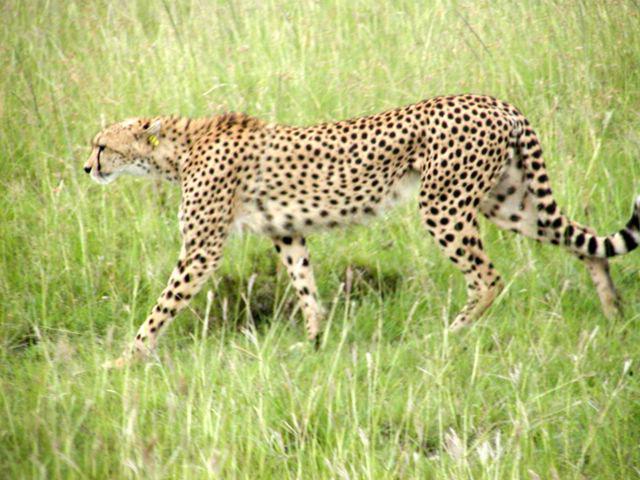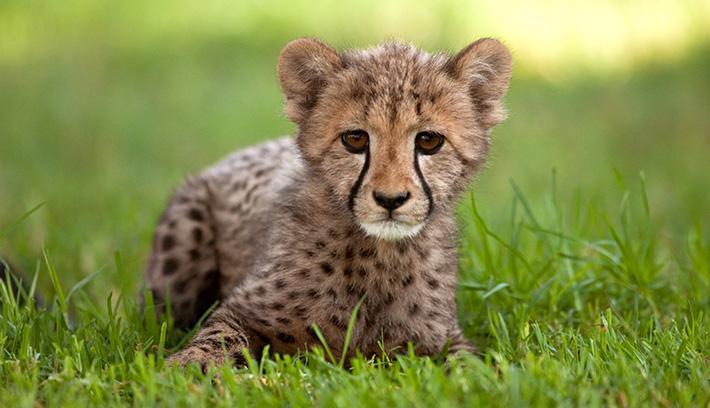The first image is the image on the left, the second image is the image on the right. Evaluate the accuracy of this statement regarding the images: "There are three cheetahs.". Is it true? Answer yes or no. No. The first image is the image on the left, the second image is the image on the right. Considering the images on both sides, is "There are two cheetahs in the image pair" valid? Answer yes or no. Yes. 